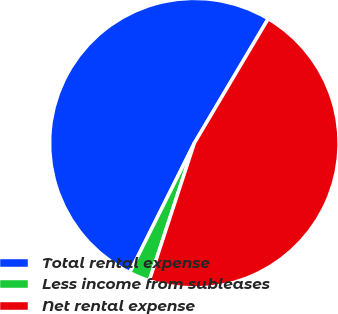<chart> <loc_0><loc_0><loc_500><loc_500><pie_chart><fcel>Total rental expense<fcel>Less income from subleases<fcel>Net rental expense<nl><fcel>51.16%<fcel>2.33%<fcel>46.51%<nl></chart> 